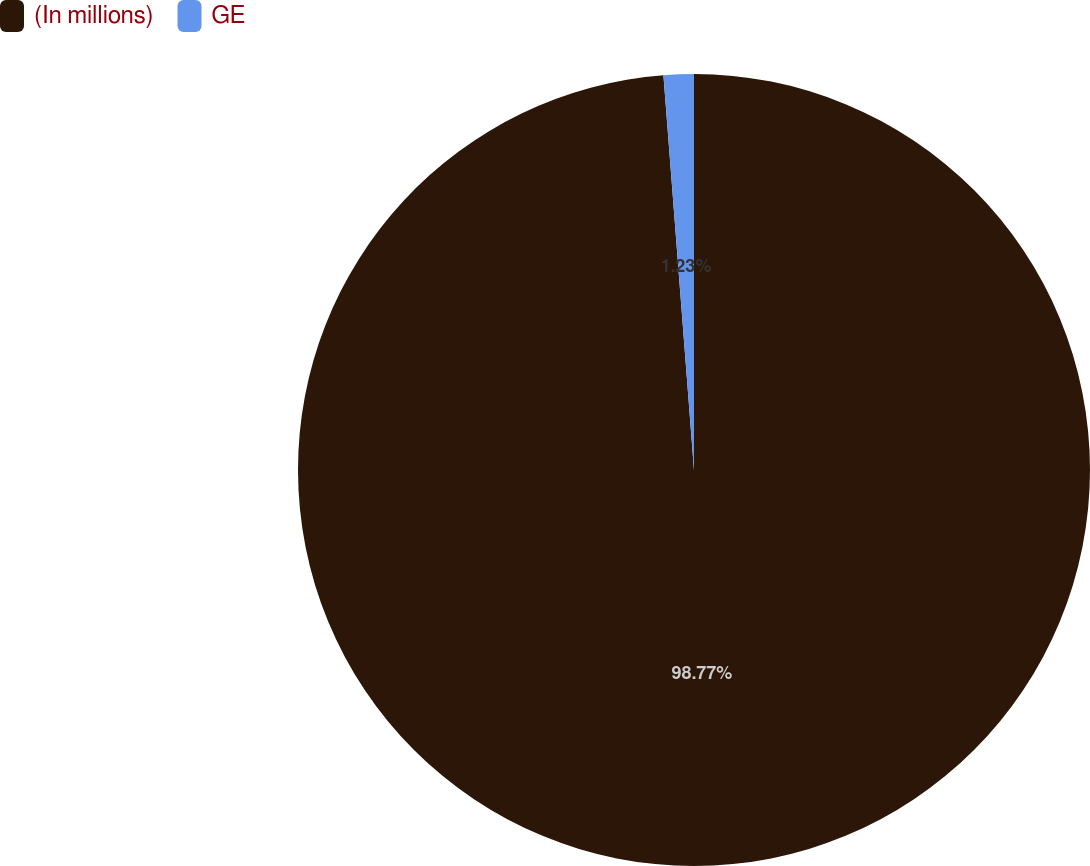<chart> <loc_0><loc_0><loc_500><loc_500><pie_chart><fcel>(In millions)<fcel>GE<nl><fcel>98.77%<fcel>1.23%<nl></chart> 